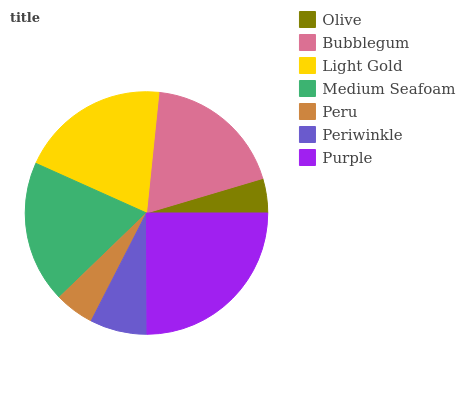Is Olive the minimum?
Answer yes or no. Yes. Is Purple the maximum?
Answer yes or no. Yes. Is Bubblegum the minimum?
Answer yes or no. No. Is Bubblegum the maximum?
Answer yes or no. No. Is Bubblegum greater than Olive?
Answer yes or no. Yes. Is Olive less than Bubblegum?
Answer yes or no. Yes. Is Olive greater than Bubblegum?
Answer yes or no. No. Is Bubblegum less than Olive?
Answer yes or no. No. Is Bubblegum the high median?
Answer yes or no. Yes. Is Bubblegum the low median?
Answer yes or no. Yes. Is Medium Seafoam the high median?
Answer yes or no. No. Is Peru the low median?
Answer yes or no. No. 